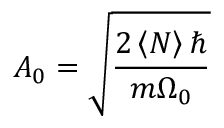<formula> <loc_0><loc_0><loc_500><loc_500>A _ { 0 } = \sqrt { \frac { 2 \left < N \right > } { m \Omega _ { 0 } } }</formula> 